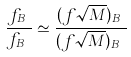Convert formula to latex. <formula><loc_0><loc_0><loc_500><loc_500>\frac { f _ { B _ { s } } } { f _ { B _ { d } } } \simeq \frac { ( f \sqrt { M } ) _ { B _ { s } } } { ( f \sqrt { M } ) _ { B _ { d } } }</formula> 